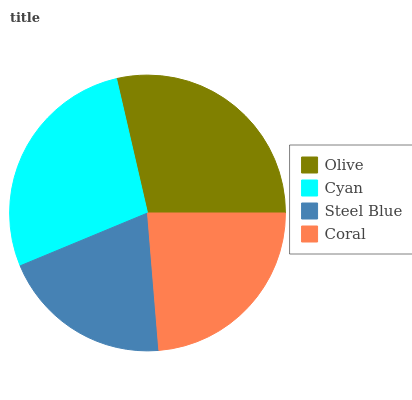Is Steel Blue the minimum?
Answer yes or no. Yes. Is Olive the maximum?
Answer yes or no. Yes. Is Cyan the minimum?
Answer yes or no. No. Is Cyan the maximum?
Answer yes or no. No. Is Olive greater than Cyan?
Answer yes or no. Yes. Is Cyan less than Olive?
Answer yes or no. Yes. Is Cyan greater than Olive?
Answer yes or no. No. Is Olive less than Cyan?
Answer yes or no. No. Is Cyan the high median?
Answer yes or no. Yes. Is Coral the low median?
Answer yes or no. Yes. Is Olive the high median?
Answer yes or no. No. Is Olive the low median?
Answer yes or no. No. 